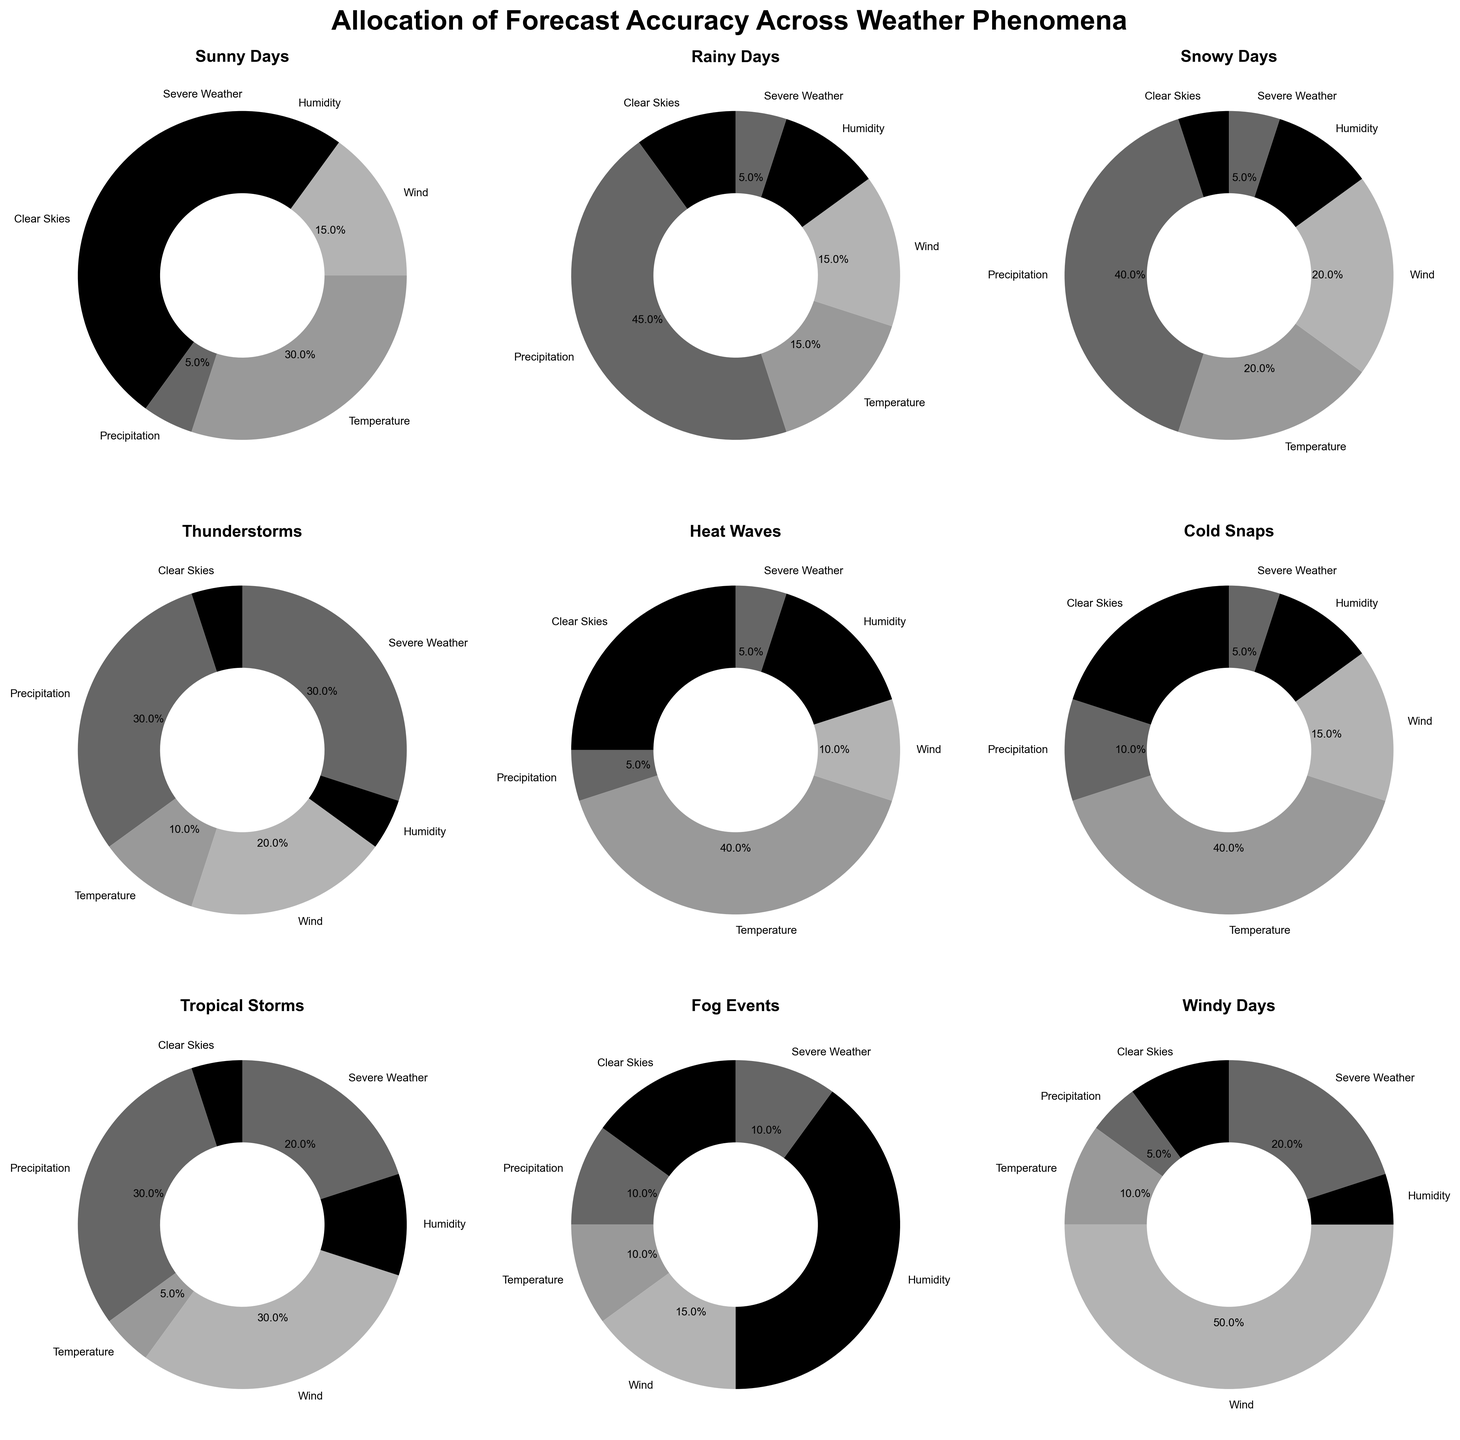Which weather phenomenon has the highest forecast accuracy for Precipitation? Observing the pie charts, Rainy Days shows a 45% allocation for Precipitation, the highest among all phenomena.
Answer: Rainy Days Compare the forecast accuracy for Severe Weather between Thunderstorms and Windy Days. Which one is higher? Thunderstorms have a 30% accuracy for Severe Weather, while Windy Days have 20%. Thunderstorms are higher.
Answer: Thunderstorms What is the average forecast accuracy for Clear Skies across Sunny Days, Rainy Days, and Snowy Days? The Clear Skies accuracy is 40% (Sunny Days), 10% (Rainy Days), and 5% (Snowy Days). Add these and divide by 3: (40+10+5)/3 = 55/3 ≈ 18.33.
Answer: 18.33% Which phenomenon has the least forecast accuracy for Wind? Checking the pie charts, Heat Waves and Rainy Days both show the lowest accuracy for Wind, which is 10%.
Answer: Heat Waves What is the sum of forecast accuracies for Temperature in Heat Waves, Cold Snaps, and Fog Events? The Temperature accuracies are 40% (Heat Waves), 40% (Cold Snaps), and 10% (Fog Events). Summing these: 40+40+10 = 90.
Answer: 90% Which weather phenomenon has a higher forecast accuracy for Humidity: Fog Events or Heat Waves? Fog Events have a 40% forecast accuracy for Humidity, whereas Heat Waves have 15%.
Answer: Fog Events How does the forecast accuracy for Severe Weather compare between Thunderstorms and Tropical Storms? Thunderstorms have a 30% accuracy for Severe Weather, while Tropical Storms have 20%. Thunderstorms is higher.
Answer: Thunderstorms What is the total forecast accuracy for Wind across Windy Days, Thunderstorms, and Tropical Storms? The Wind accuracies are 50% (Windy Days), 20% (Thunderstorms), and 30% (Tropical Storms). Summing these: 50+20+30 = 100.
Answer: 100% Which phenomenon has the highest forecast accuracy for Temperature? From the pie charts, Heat Waves have the highest forecast accuracy for Temperature at 40%.
Answer: Heat Waves Compare the forecast accuracy for Clear Skies between Drought Conditions and Thunderstorms. Which one is higher? Drought Conditions have a 35% forecast accuracy for Clear Skies, whereas Thunderstorms have 5%.
Answer: Drought Conditions 